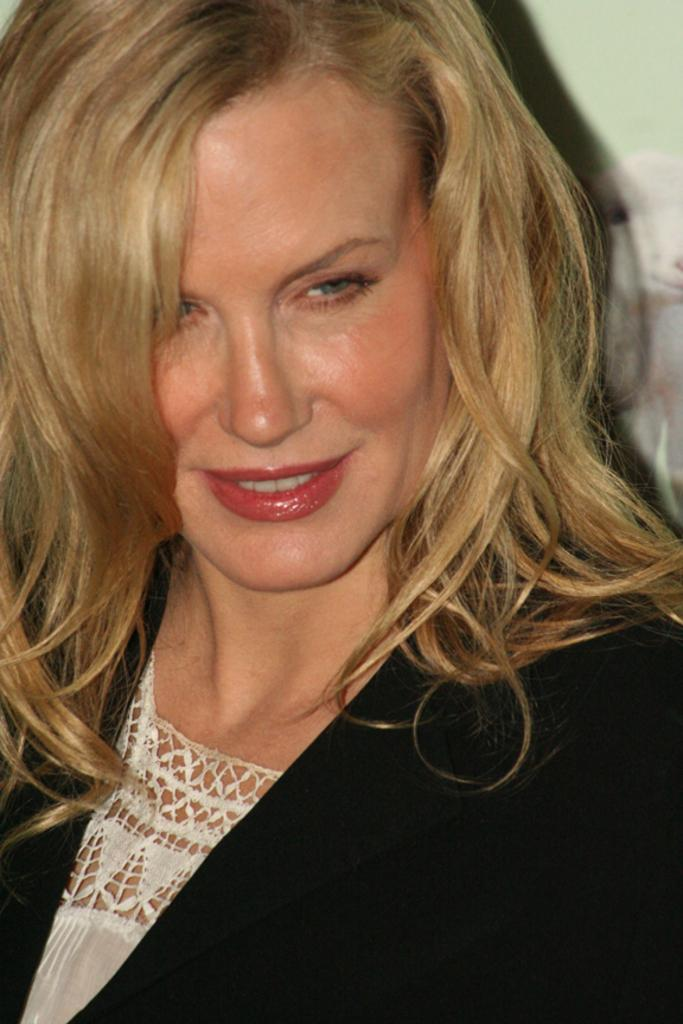Who is present in the image? There is a woman in the image. What is the woman doing in the image? The woman is smiling in the image. What is the woman wearing in the image? The woman is wearing a black coat in the image. How many children are playing with the tray in the image? There is no tray or children present in the image. 